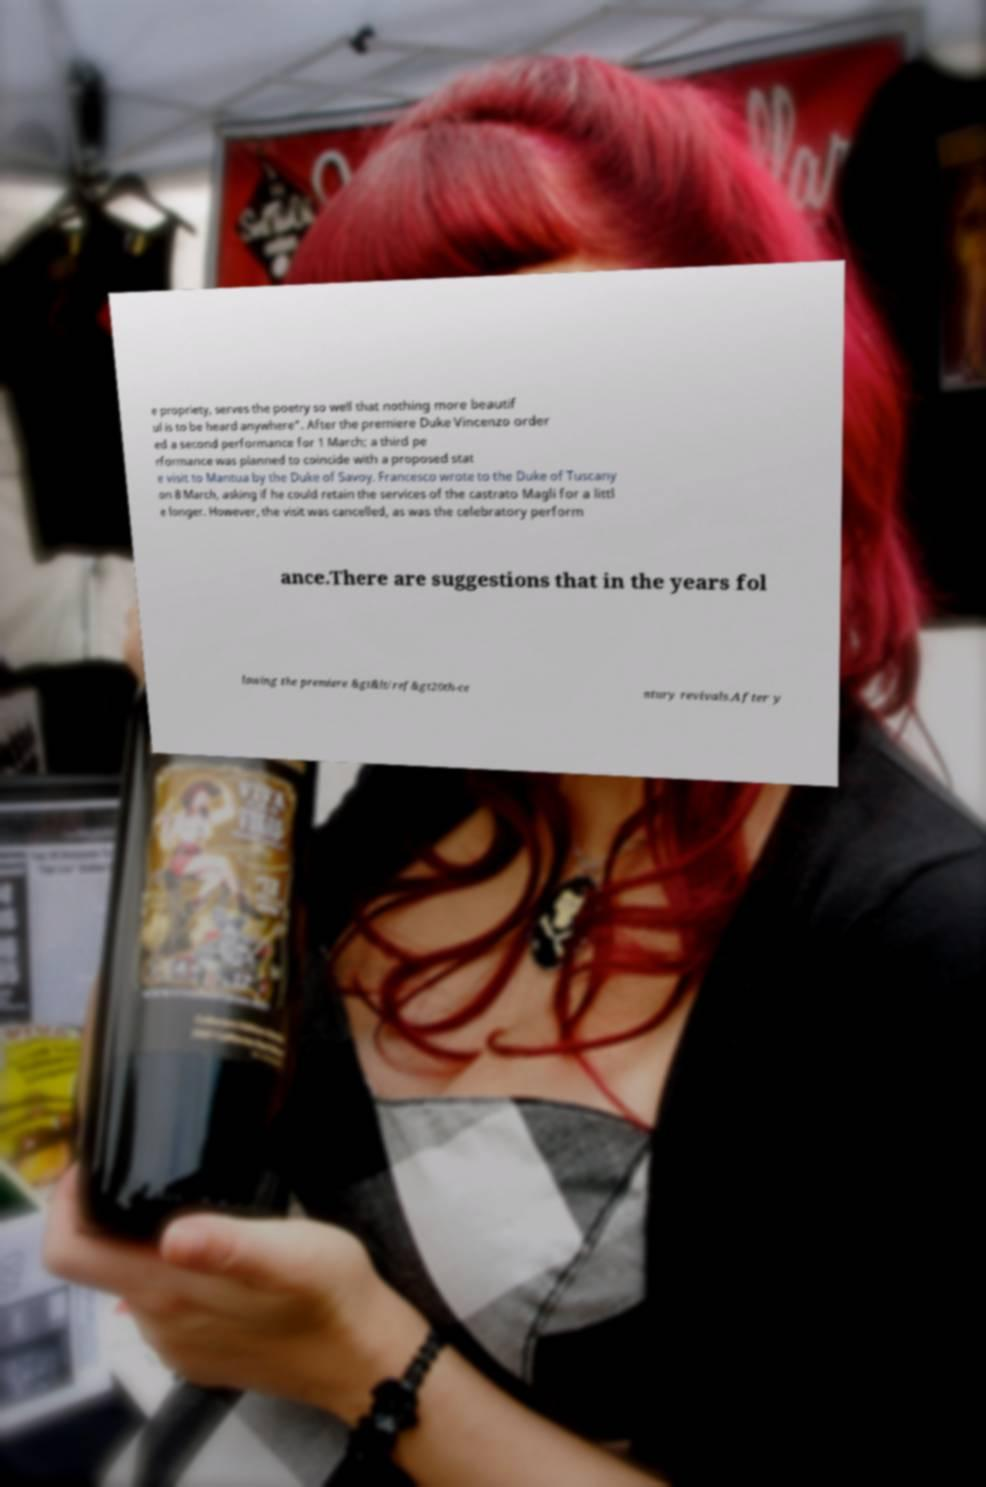What messages or text are displayed in this image? I need them in a readable, typed format. e propriety, serves the poetry so well that nothing more beautif ul is to be heard anywhere". After the premiere Duke Vincenzo order ed a second performance for 1 March; a third pe rformance was planned to coincide with a proposed stat e visit to Mantua by the Duke of Savoy. Francesco wrote to the Duke of Tuscany on 8 March, asking if he could retain the services of the castrato Magli for a littl e longer. However, the visit was cancelled, as was the celebratory perform ance.There are suggestions that in the years fol lowing the premiere &gt&lt/ref&gt20th-ce ntury revivals.After y 